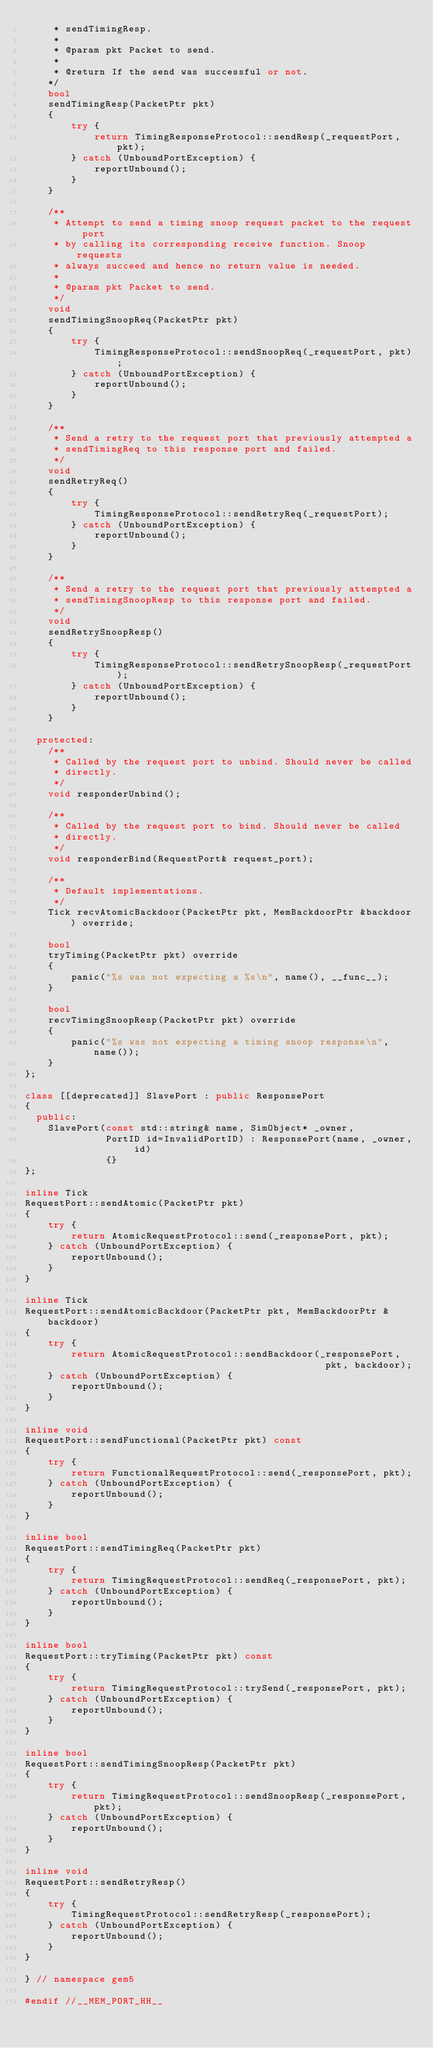Convert code to text. <code><loc_0><loc_0><loc_500><loc_500><_C++_>     * sendTimingResp.
     *
     * @param pkt Packet to send.
     *
     * @return If the send was successful or not.
    */
    bool
    sendTimingResp(PacketPtr pkt)
    {
        try {
            return TimingResponseProtocol::sendResp(_requestPort, pkt);
        } catch (UnboundPortException) {
            reportUnbound();
        }
    }

    /**
     * Attempt to send a timing snoop request packet to the request port
     * by calling its corresponding receive function. Snoop requests
     * always succeed and hence no return value is needed.
     *
     * @param pkt Packet to send.
     */
    void
    sendTimingSnoopReq(PacketPtr pkt)
    {
        try {
            TimingResponseProtocol::sendSnoopReq(_requestPort, pkt);
        } catch (UnboundPortException) {
            reportUnbound();
        }
    }

    /**
     * Send a retry to the request port that previously attempted a
     * sendTimingReq to this response port and failed.
     */
    void
    sendRetryReq()
    {
        try {
            TimingResponseProtocol::sendRetryReq(_requestPort);
        } catch (UnboundPortException) {
            reportUnbound();
        }
    }

    /**
     * Send a retry to the request port that previously attempted a
     * sendTimingSnoopResp to this response port and failed.
     */
    void
    sendRetrySnoopResp()
    {
        try {
            TimingResponseProtocol::sendRetrySnoopResp(_requestPort);
        } catch (UnboundPortException) {
            reportUnbound();
        }
    }

  protected:
    /**
     * Called by the request port to unbind. Should never be called
     * directly.
     */
    void responderUnbind();

    /**
     * Called by the request port to bind. Should never be called
     * directly.
     */
    void responderBind(RequestPort& request_port);

    /**
     * Default implementations.
     */
    Tick recvAtomicBackdoor(PacketPtr pkt, MemBackdoorPtr &backdoor) override;

    bool
    tryTiming(PacketPtr pkt) override
    {
        panic("%s was not expecting a %s\n", name(), __func__);
    }

    bool
    recvTimingSnoopResp(PacketPtr pkt) override
    {
        panic("%s was not expecting a timing snoop response\n", name());
    }
};

class [[deprecated]] SlavePort : public ResponsePort
{
  public:
    SlavePort(const std::string& name, SimObject* _owner,
              PortID id=InvalidPortID) : ResponsePort(name, _owner, id)
              {}
};

inline Tick
RequestPort::sendAtomic(PacketPtr pkt)
{
    try {
        return AtomicRequestProtocol::send(_responsePort, pkt);
    } catch (UnboundPortException) {
        reportUnbound();
    }
}

inline Tick
RequestPort::sendAtomicBackdoor(PacketPtr pkt, MemBackdoorPtr &backdoor)
{
    try {
        return AtomicRequestProtocol::sendBackdoor(_responsePort,
                                                    pkt, backdoor);
    } catch (UnboundPortException) {
        reportUnbound();
    }
}

inline void
RequestPort::sendFunctional(PacketPtr pkt) const
{
    try {
        return FunctionalRequestProtocol::send(_responsePort, pkt);
    } catch (UnboundPortException) {
        reportUnbound();
    }
}

inline bool
RequestPort::sendTimingReq(PacketPtr pkt)
{
    try {
        return TimingRequestProtocol::sendReq(_responsePort, pkt);
    } catch (UnboundPortException) {
        reportUnbound();
    }
}

inline bool
RequestPort::tryTiming(PacketPtr pkt) const
{
    try {
        return TimingRequestProtocol::trySend(_responsePort, pkt);
    } catch (UnboundPortException) {
        reportUnbound();
    }
}

inline bool
RequestPort::sendTimingSnoopResp(PacketPtr pkt)
{
    try {
        return TimingRequestProtocol::sendSnoopResp(_responsePort, pkt);
    } catch (UnboundPortException) {
        reportUnbound();
    }
}

inline void
RequestPort::sendRetryResp()
{
    try {
        TimingRequestProtocol::sendRetryResp(_responsePort);
    } catch (UnboundPortException) {
        reportUnbound();
    }
}

} // namespace gem5

#endif //__MEM_PORT_HH__
</code> 